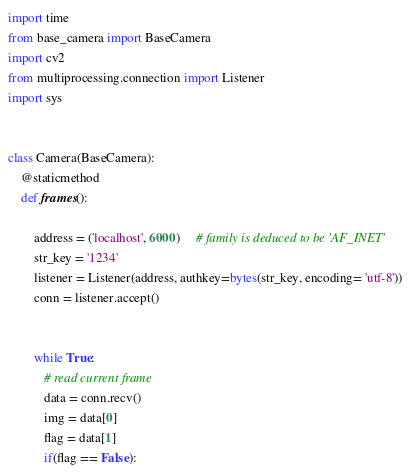Convert code to text. <code><loc_0><loc_0><loc_500><loc_500><_Python_>import time
from base_camera import BaseCamera
import cv2
from multiprocessing.connection import Listener
import sys


class Camera(BaseCamera):
    @staticmethod
    def frames():

        address = ('localhost', 6000)     # family is deduced to be 'AF_INET'
        str_key = '1234'
        listener = Listener(address, authkey=bytes(str_key, encoding= 'utf-8'))
        conn = listener.accept()
 

        while True:
           # read current frame
           data = conn.recv()
           img = data[0]
           flag = data[1]
           if(flag == False):</code> 